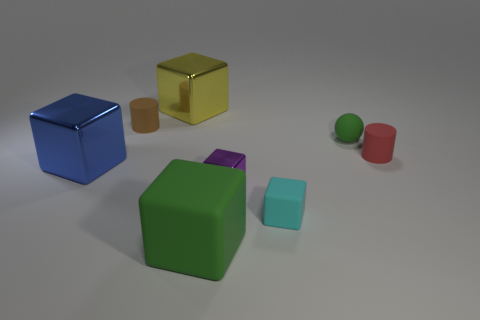What shape is the green thing that is the same size as the red cylinder?
Your answer should be very brief. Sphere. There is a large blue shiny thing; are there any large green rubber cubes left of it?
Your answer should be very brief. No. Does the green thing that is right of the small cyan object have the same material as the tiny cylinder that is on the right side of the tiny purple object?
Provide a succinct answer. Yes. How many brown matte things have the same size as the cyan matte object?
Your response must be concise. 1. There is another rubber object that is the same color as the big matte thing; what shape is it?
Make the answer very short. Sphere. There is a cyan block that is in front of the blue metal object; what is it made of?
Your answer should be very brief. Rubber. How many yellow things have the same shape as the brown matte object?
Offer a very short reply. 0. What is the shape of the brown thing that is made of the same material as the big green cube?
Make the answer very short. Cylinder. What shape is the small matte object in front of the shiny thing in front of the big shiny thing that is to the left of the big yellow block?
Your answer should be very brief. Cube. Are there more cubes than big blue matte cubes?
Ensure brevity in your answer.  Yes. 